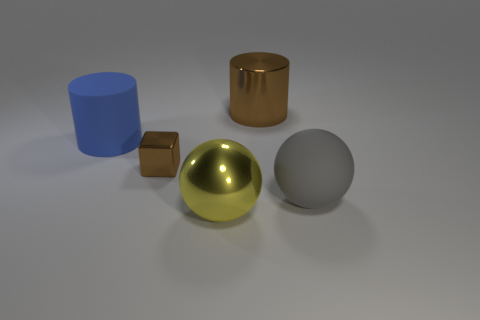There is a blue cylinder that is the same size as the metallic sphere; what material is it?
Offer a terse response. Rubber. Do the brown cylinder and the blue object have the same material?
Your answer should be compact. No. There is a big thing that is both behind the metal cube and on the right side of the large blue matte cylinder; what color is it?
Offer a terse response. Brown. There is a ball in front of the matte sphere; is its color the same as the metal cylinder?
Give a very brief answer. No. What is the shape of the shiny thing that is the same size as the yellow shiny ball?
Ensure brevity in your answer.  Cylinder. How many other things are there of the same color as the metal cylinder?
Offer a terse response. 1. What number of other objects are the same material as the big brown cylinder?
Offer a terse response. 2. Do the matte sphere and the brown object that is in front of the big brown metal cylinder have the same size?
Your answer should be very brief. No. What is the color of the metallic ball?
Ensure brevity in your answer.  Yellow. There is a large rubber thing that is on the right side of the big rubber object that is on the left side of the large matte thing to the right of the blue object; what shape is it?
Keep it short and to the point. Sphere. 